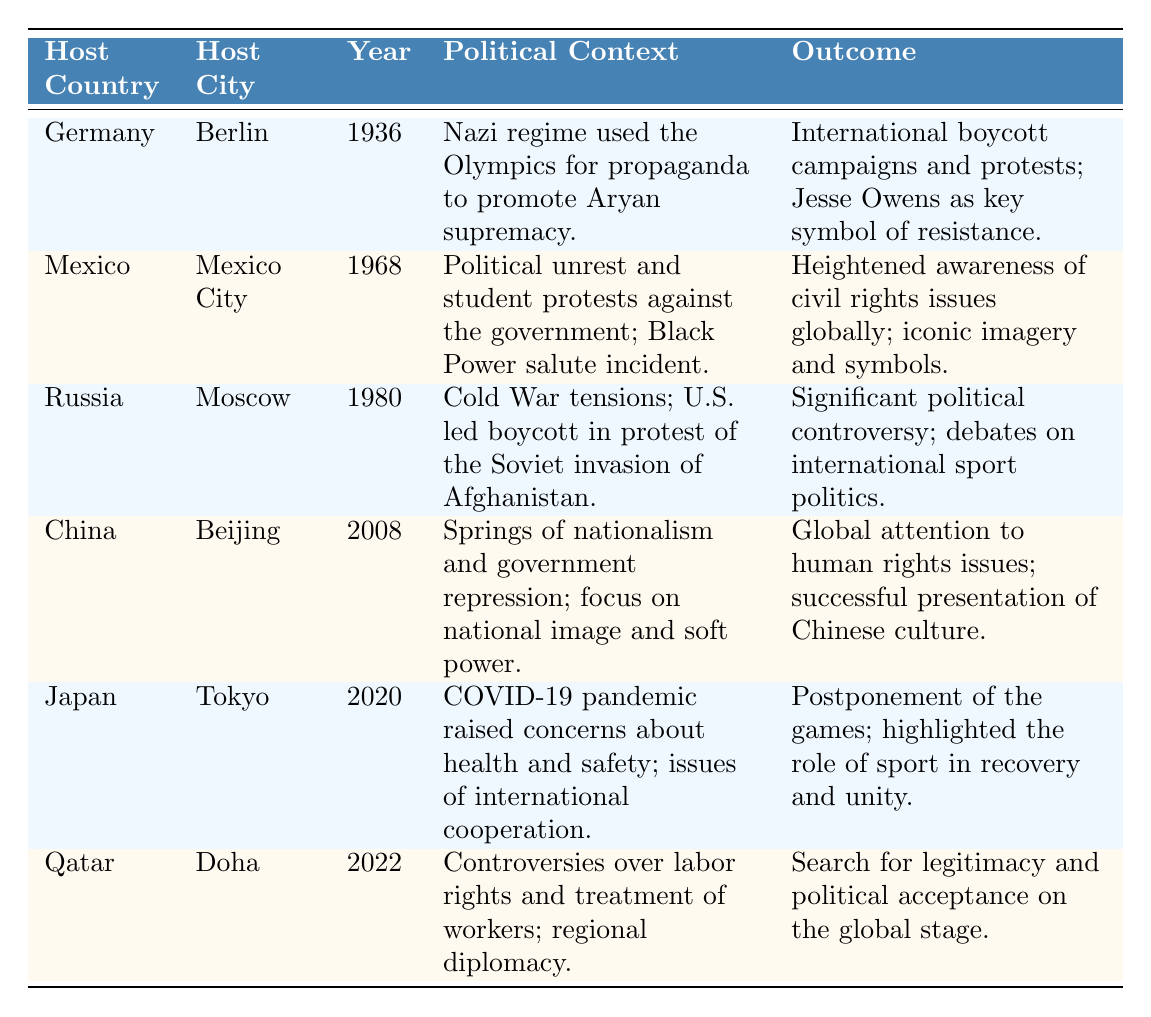What year did Germany host the Olympics? The table lists Germany as the host country for the Olympics in the year 1936.
Answer: 1936 What was the political context of the Mexico City Olympics in 1968? The table states that there was political unrest and student protests against the government, along with the Black Power salute incident.
Answer: Political unrest and student protests against the government; Black Power salute incident Did any host country face international boycotts during the Olympics? Yes, the table indicates that both Germany in 1936 and Russia in 1980 faced international boycotts or protests related to the political context of their host years.
Answer: Yes What was the outcome of the Beijing Olympics in 2008? The table mentions that the outcome included global attention to human rights issues and a successful presentation of Chinese culture.
Answer: Global attention to human rights issues; successful presentation of Chinese culture Which Olympic host country selected a host city that experienced significant political controversy? According to the table, Russia hosted the Olympics in Moscow in 1980, which is noted for significant political controversy due to the U.S. led boycott and Cold War tensions.
Answer: Russia (Moscow, 1980) What are the two key outcomes mentioned for the Tokyo 2020 Olympics? The table explains that the outcomes were the postponement of the games and highlighted the role of sport in recovery and unity.
Answer: Postponement of the games; highlighted the role of sport in recovery and unity Was there a focus on national image and soft power in any Olympic selections? Yes, the table shows that during the Beijing 2008 Olympics, there was a focus on national image and soft power amidst nationalism and government repression.
Answer: Yes Which Olympic year had a political context centered around labor rights? The table specifies that the Qatar Olympics in 2022 had a political context regarding controversies over labor rights and treatment of workers.
Answer: 2022 What does the table reveal about the political context regarding international cooperation for the Tokyo 2020 Olympics? It indicates that the COVID-19 pandemic raised concerns about health and safety and highlighted issues of international cooperation during the Tokyo 2020 Olympics.
Answer: Concerns about health and safety; issues of international cooperation 